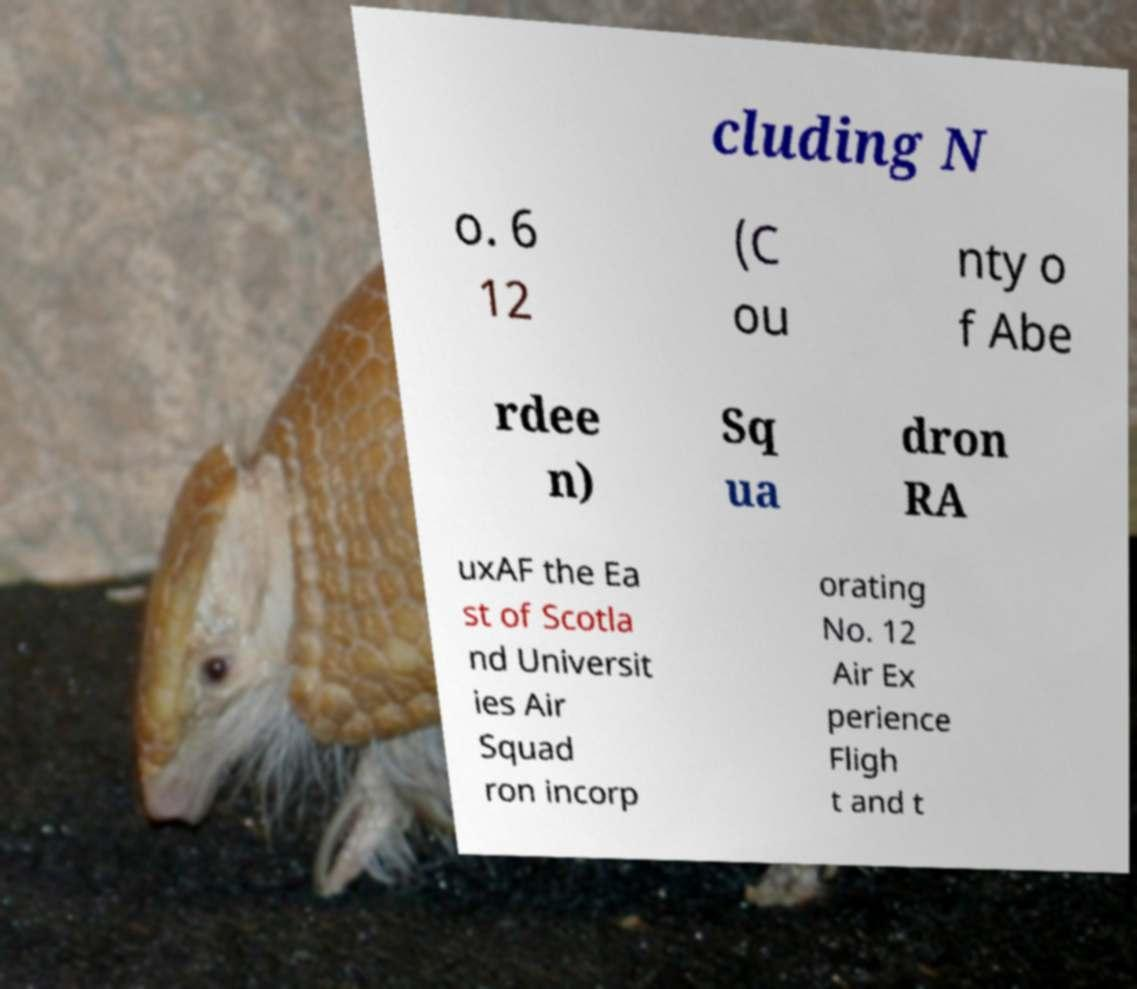Can you accurately transcribe the text from the provided image for me? cluding N o. 6 12 (C ou nty o f Abe rdee n) Sq ua dron RA uxAF the Ea st of Scotla nd Universit ies Air Squad ron incorp orating No. 12 Air Ex perience Fligh t and t 